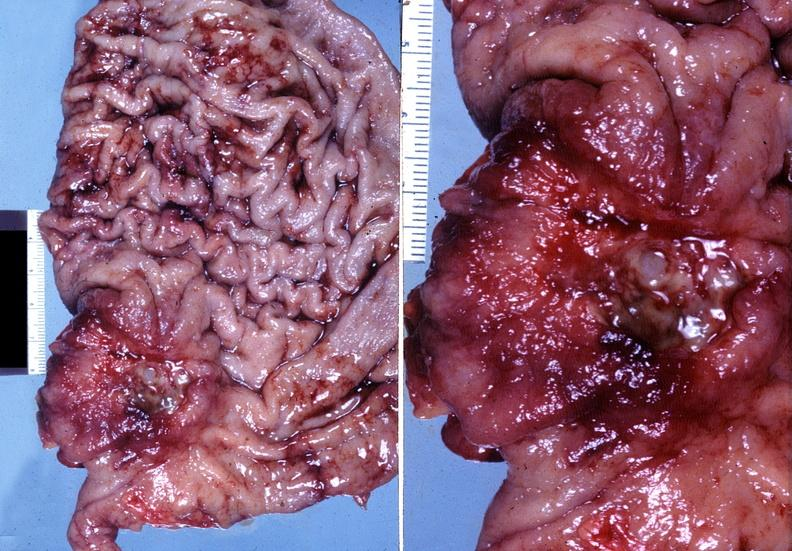does this section show stomach, adenocarcinoma?
Answer the question using a single word or phrase. No 